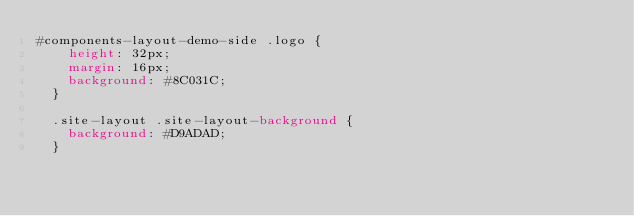<code> <loc_0><loc_0><loc_500><loc_500><_CSS_>#components-layout-demo-side .logo {
    height: 32px;
    margin: 16px;
    background: #8C031C;
  }
  
  .site-layout .site-layout-background {
    background: #D9ADAD;
  }</code> 